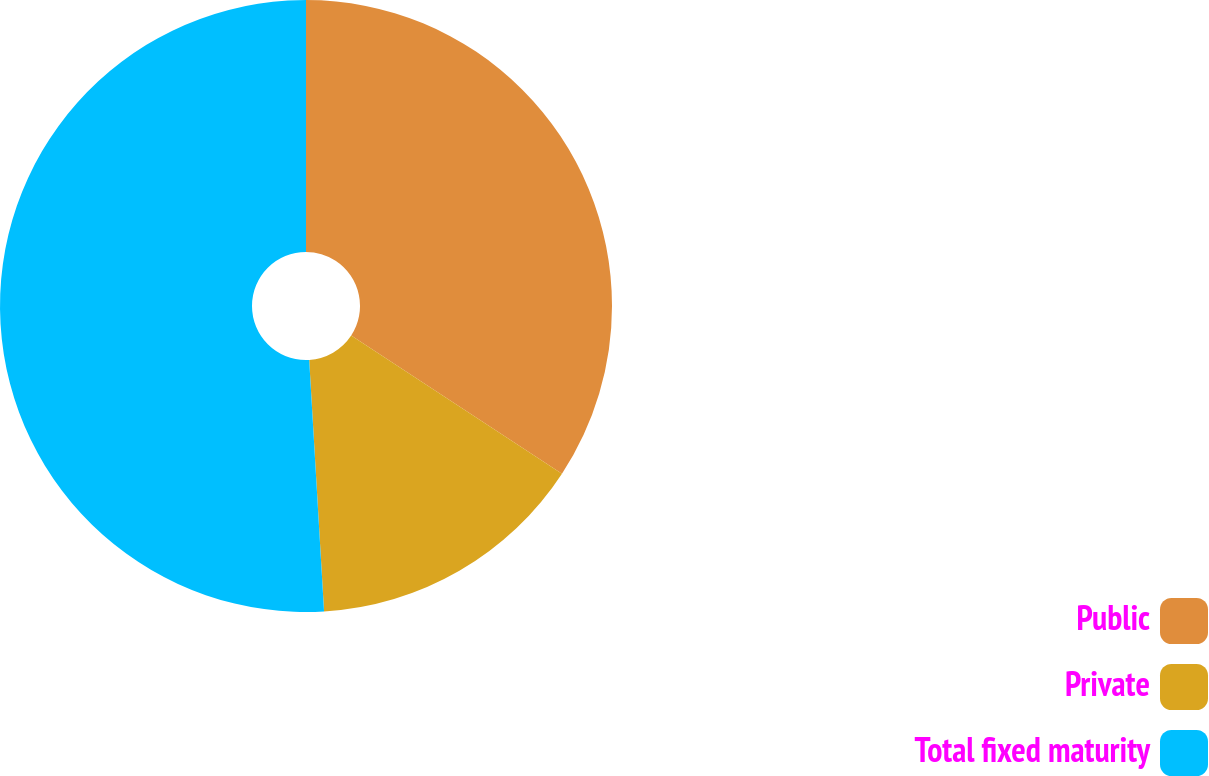Convert chart. <chart><loc_0><loc_0><loc_500><loc_500><pie_chart><fcel>Public<fcel>Private<fcel>Total fixed maturity<nl><fcel>34.23%<fcel>14.83%<fcel>50.94%<nl></chart> 